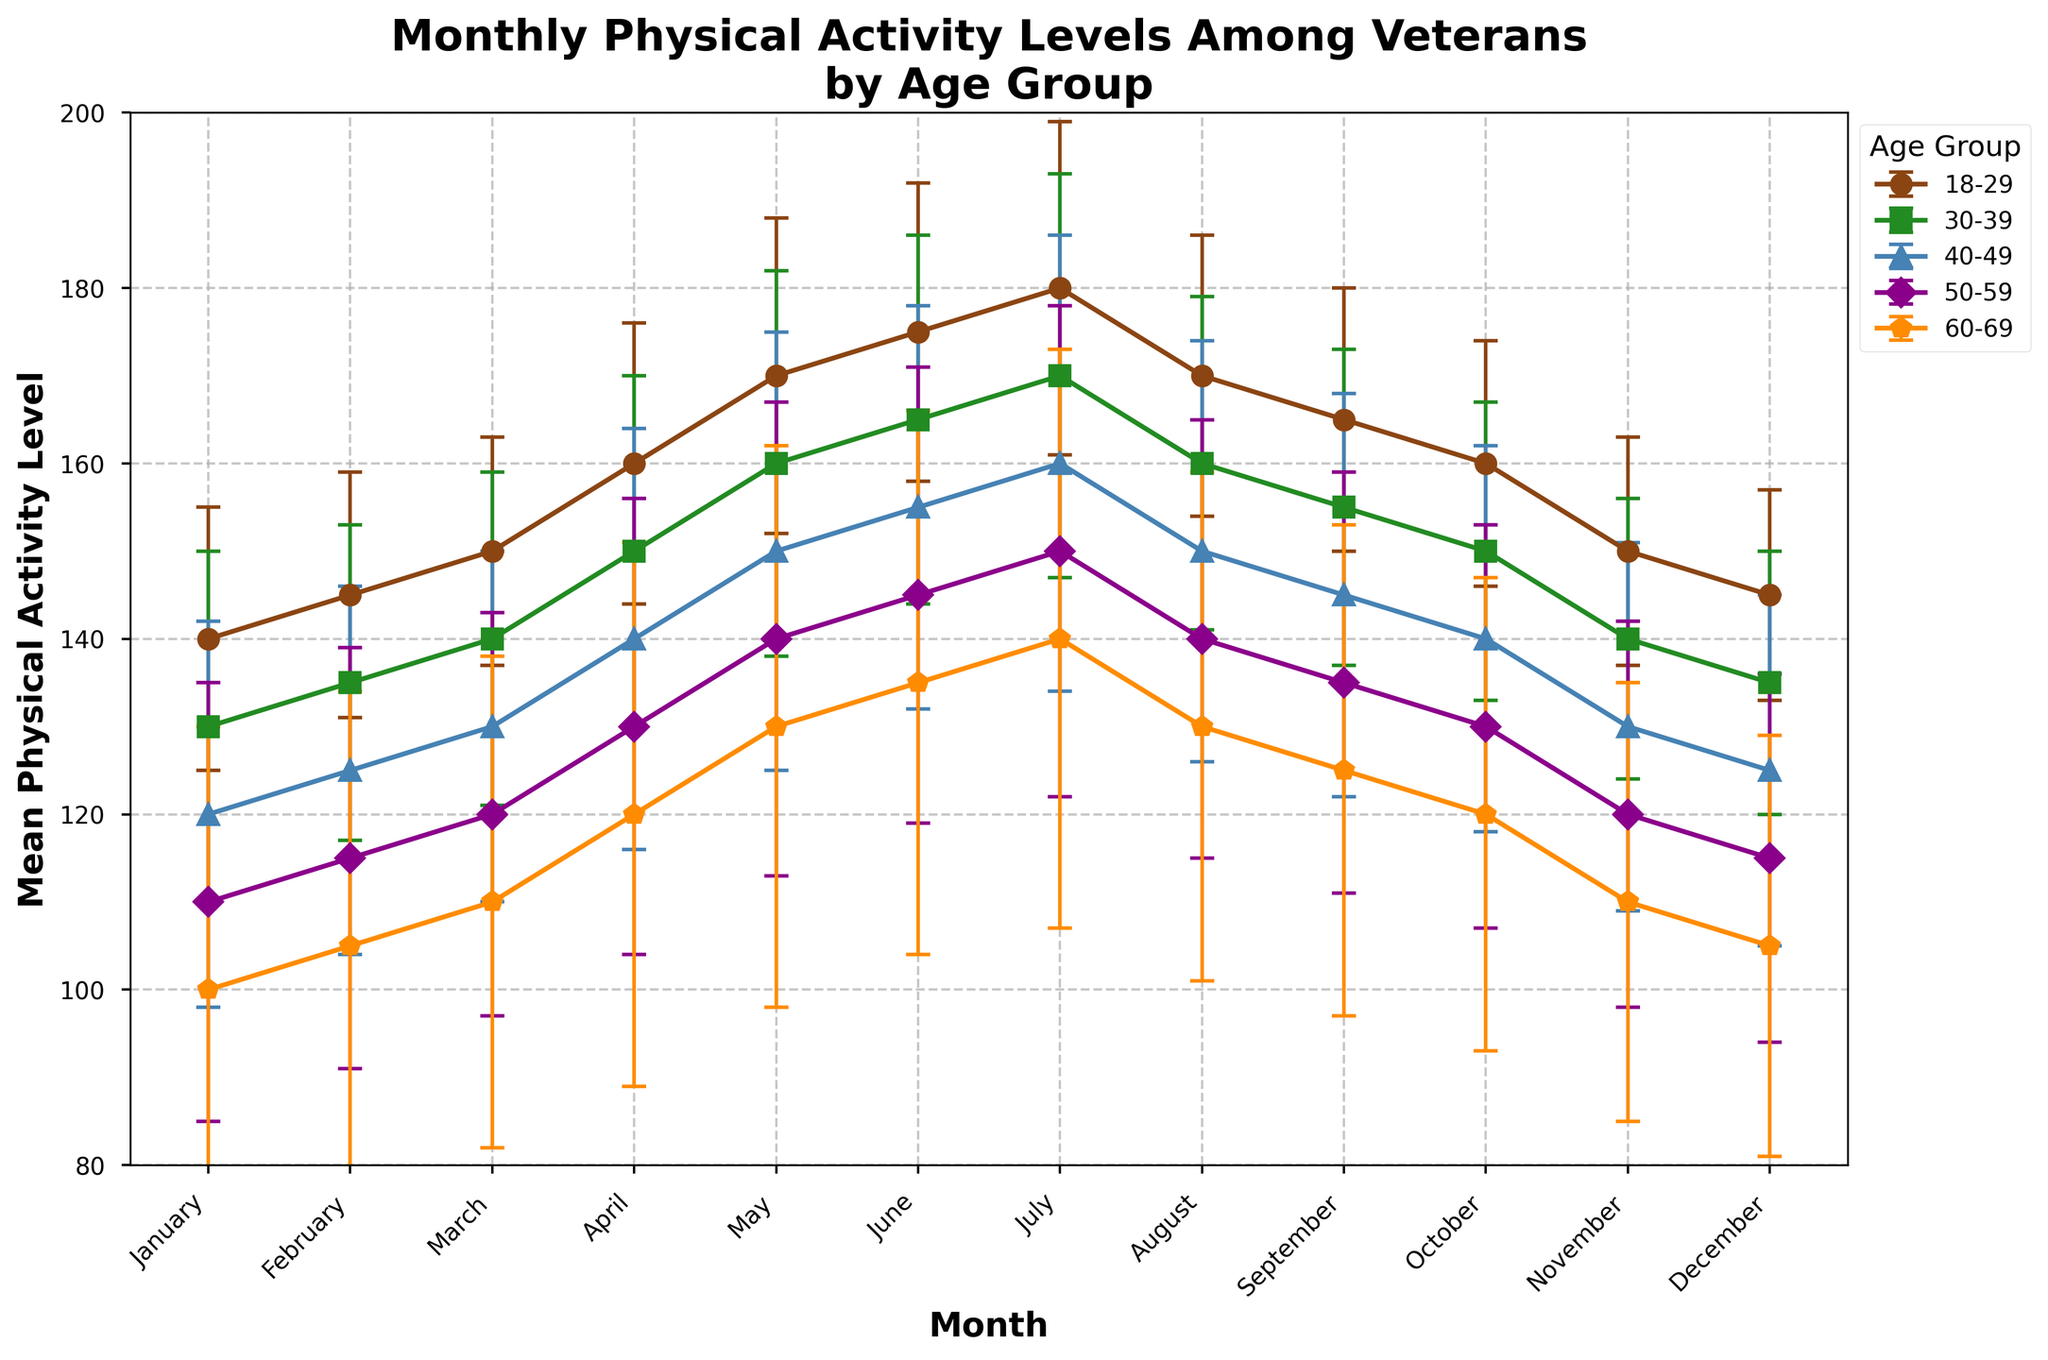What's the title of the figure? The title is displayed at the top of the figure. It helps summarize what the figure is about. In this case, it says "Monthly Physical Activity Levels Among Veterans by Age Group."
Answer: Monthly Physical Activity Levels Among Veterans by Age Group What are the age groups represented in the plot? Each line represents a different age group. The legend on the right side of the plot lists all the age groups. These are "18-29", "30-39", "40-49", "50-59", "60-69".
Answer: 18-29, 30-39, 40-49, 50-59, 60-69 Which month shows the highest physical activity level for the 18-29 age group? By following the line and looking at the y-values corresponding to each month for the 18-29 age group, we see the highest point is in July, where the physical activity level reaches 180.
Answer: July What is the average physical activity level in December for all age groups combined? Extract the physical activity levels for each age group in December: 145 (18-29), 135 (30-39), 125 (40-49), 115 (50-59), 105 (60-69). Summing these gives 625. Dividing by 5 (number of age groups) gives 625/5 = 125.
Answer: 125 Which age group shows the most variation in physical activity levels throughout the year? The standard deviation (variability) is represented by the error bars. By comparing the sizes of the error bars, the 60-69 age group shows visibly larger error bars, indicating more variation in activity levels.
Answer: 60-69 In which months do all age groups show a decline after previously increasing? Examine the trends in activity levels month by month. May to August show an increase and then a decline for most groups, particularly visible in the 18-29, 30-39, 40-49, and 50-59 groups.
Answer: August How does the physical activity level trend for the 30-39 age group from June to October? Follow the 30-39 age group's line from June to October: June (165), July (170), August (160), September (155), October (150). It shows a decreasing trend.
Answer: Decreasing Which age group consistently has the lowest average physical activity level throughout the year? By visually scanning the lines, the 60-69 age group is consistently the lowest throughout the months compared to other age groups.
Answer: 60-69 